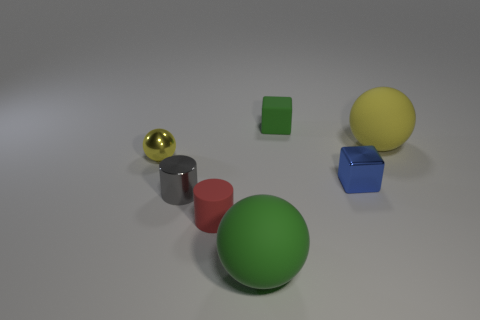There is a red cylinder that is the same size as the yellow shiny object; what is it made of?
Provide a succinct answer. Rubber. Are there any large green objects that have the same material as the gray cylinder?
Give a very brief answer. No. There is a tiny gray metallic thing; is it the same shape as the thing that is left of the tiny gray metal cylinder?
Offer a very short reply. No. How many objects are behind the blue thing and on the left side of the green rubber ball?
Give a very brief answer. 1. Is the large yellow ball made of the same material as the block that is in front of the tiny green matte block?
Provide a short and direct response. No. Are there an equal number of rubber balls that are on the left side of the small green rubber thing and large red cylinders?
Give a very brief answer. No. What color is the sphere that is on the left side of the red cylinder?
Your response must be concise. Yellow. How many other things are there of the same color as the matte cylinder?
Provide a short and direct response. 0. Does the yellow ball that is on the right side of the metal ball have the same size as the green ball?
Your answer should be very brief. Yes. There is a tiny block that is to the left of the metallic cube; what is it made of?
Provide a succinct answer. Rubber. 